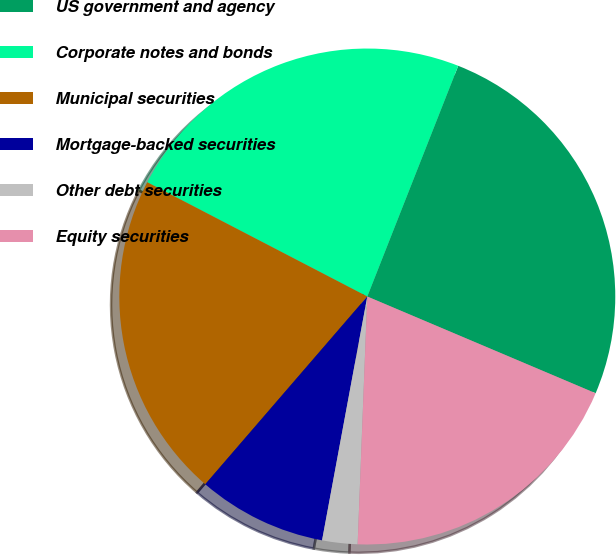<chart> <loc_0><loc_0><loc_500><loc_500><pie_chart><fcel>US government and agency<fcel>Corporate notes and bonds<fcel>Municipal securities<fcel>Mortgage-backed securities<fcel>Other debt securities<fcel>Equity securities<nl><fcel>25.4%<fcel>23.35%<fcel>21.29%<fcel>8.41%<fcel>2.3%<fcel>19.24%<nl></chart> 